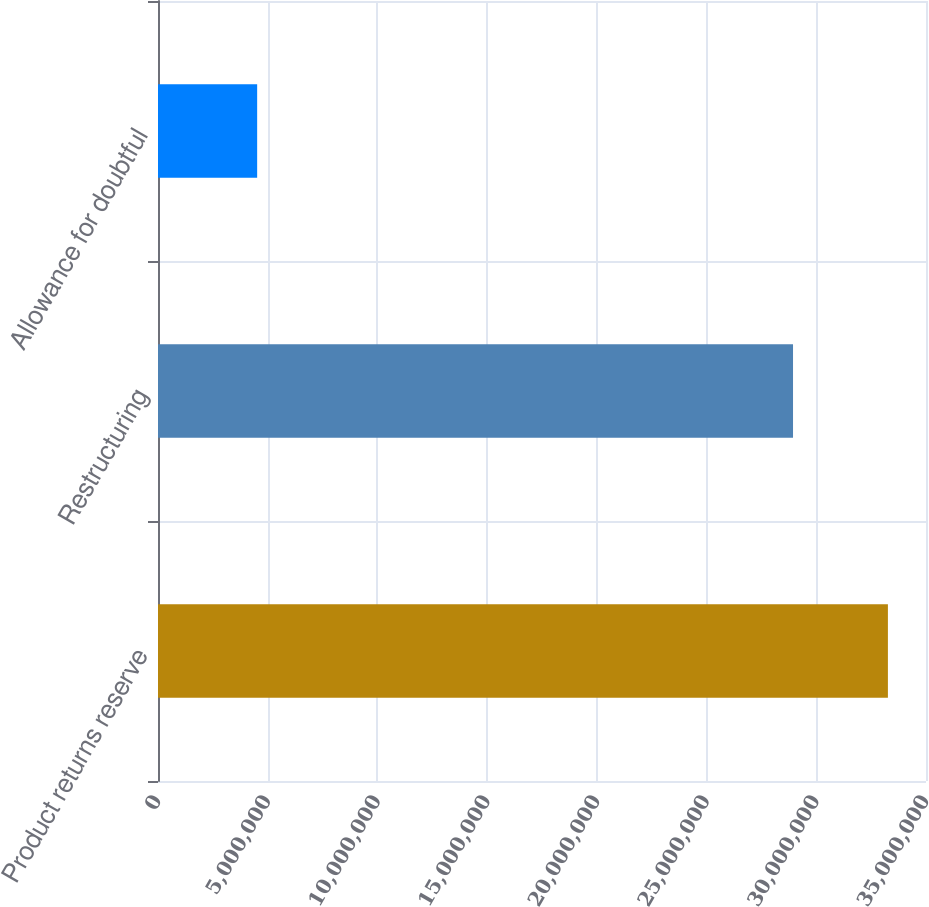<chart> <loc_0><loc_0><loc_500><loc_500><bar_chart><fcel>Product returns reserve<fcel>Restructuring<fcel>Allowance for doubtful<nl><fcel>3.3264e+07<fcel>2.894e+07<fcel>4.519e+06<nl></chart> 